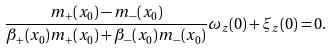Convert formula to latex. <formula><loc_0><loc_0><loc_500><loc_500>\frac { m _ { + } ( x _ { 0 } ) - m _ { - } ( x _ { 0 } ) } { \beta _ { + } ( x _ { 0 } ) m _ { + } ( x _ { 0 } ) + \beta _ { - } ( x _ { 0 } ) m _ { - } ( x _ { 0 } ) } \omega _ { z } ( 0 ) + \xi _ { z } ( 0 ) = 0 .</formula> 